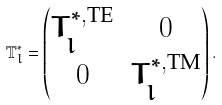Convert formula to latex. <formula><loc_0><loc_0><loc_500><loc_500>\mathbb { T } _ { l } ^ { * } = \begin{pmatrix} T ^ { * , \text {TE} } _ { l } & 0 \\ 0 & T _ { l } ^ { * , \text {TM} } \end{pmatrix} .</formula> 